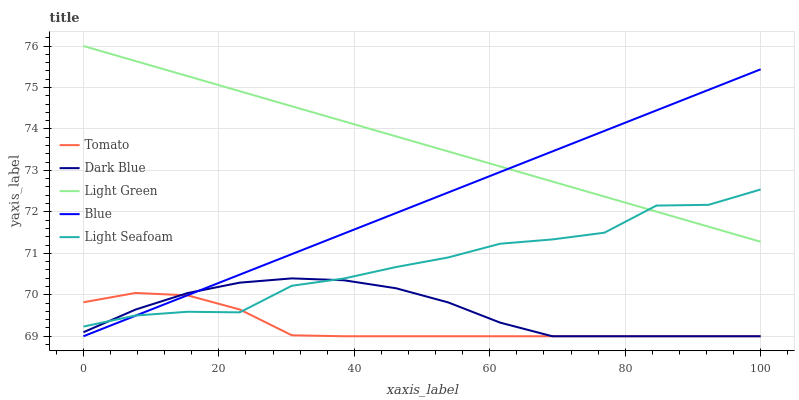Does Tomato have the minimum area under the curve?
Answer yes or no. Yes. Does Light Green have the maximum area under the curve?
Answer yes or no. Yes. Does Dark Blue have the minimum area under the curve?
Answer yes or no. No. Does Dark Blue have the maximum area under the curve?
Answer yes or no. No. Is Blue the smoothest?
Answer yes or no. Yes. Is Light Seafoam the roughest?
Answer yes or no. Yes. Is Dark Blue the smoothest?
Answer yes or no. No. Is Dark Blue the roughest?
Answer yes or no. No. Does Tomato have the lowest value?
Answer yes or no. Yes. Does Light Seafoam have the lowest value?
Answer yes or no. No. Does Light Green have the highest value?
Answer yes or no. Yes. Does Dark Blue have the highest value?
Answer yes or no. No. Is Tomato less than Light Green?
Answer yes or no. Yes. Is Light Green greater than Tomato?
Answer yes or no. Yes. Does Light Seafoam intersect Dark Blue?
Answer yes or no. Yes. Is Light Seafoam less than Dark Blue?
Answer yes or no. No. Is Light Seafoam greater than Dark Blue?
Answer yes or no. No. Does Tomato intersect Light Green?
Answer yes or no. No. 